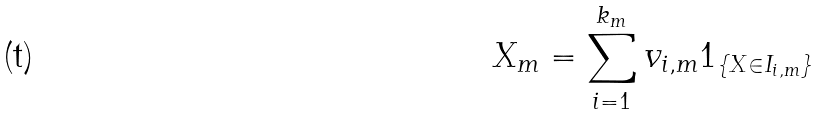Convert formula to latex. <formula><loc_0><loc_0><loc_500><loc_500>X _ { m } = \sum _ { i = 1 } ^ { k _ { m } } v _ { i , m } 1 _ { \{ X \in I _ { i , m } \} }</formula> 